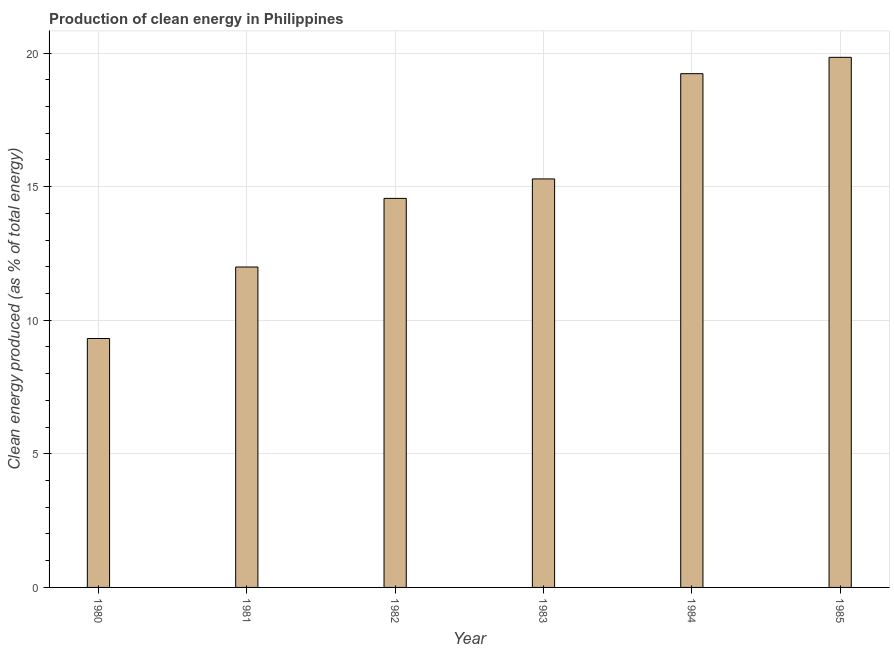What is the title of the graph?
Provide a succinct answer. Production of clean energy in Philippines. What is the label or title of the X-axis?
Offer a terse response. Year. What is the label or title of the Y-axis?
Keep it short and to the point. Clean energy produced (as % of total energy). What is the production of clean energy in 1982?
Offer a terse response. 14.56. Across all years, what is the maximum production of clean energy?
Ensure brevity in your answer.  19.84. Across all years, what is the minimum production of clean energy?
Provide a succinct answer. 9.32. In which year was the production of clean energy maximum?
Give a very brief answer. 1985. What is the sum of the production of clean energy?
Your answer should be very brief. 90.24. What is the difference between the production of clean energy in 1980 and 1985?
Your answer should be compact. -10.53. What is the average production of clean energy per year?
Provide a succinct answer. 15.04. What is the median production of clean energy?
Keep it short and to the point. 14.93. In how many years, is the production of clean energy greater than 6 %?
Keep it short and to the point. 6. What is the ratio of the production of clean energy in 1980 to that in 1981?
Offer a very short reply. 0.78. Is the production of clean energy in 1983 less than that in 1984?
Your answer should be very brief. Yes. What is the difference between the highest and the second highest production of clean energy?
Your answer should be compact. 0.61. Is the sum of the production of clean energy in 1981 and 1985 greater than the maximum production of clean energy across all years?
Provide a succinct answer. Yes. What is the difference between the highest and the lowest production of clean energy?
Keep it short and to the point. 10.52. Are all the bars in the graph horizontal?
Your answer should be compact. No. How many years are there in the graph?
Ensure brevity in your answer.  6. What is the difference between two consecutive major ticks on the Y-axis?
Ensure brevity in your answer.  5. Are the values on the major ticks of Y-axis written in scientific E-notation?
Your answer should be very brief. No. What is the Clean energy produced (as % of total energy) in 1980?
Provide a succinct answer. 9.32. What is the Clean energy produced (as % of total energy) of 1981?
Your answer should be very brief. 11.99. What is the Clean energy produced (as % of total energy) in 1982?
Your answer should be very brief. 14.56. What is the Clean energy produced (as % of total energy) in 1983?
Offer a terse response. 15.29. What is the Clean energy produced (as % of total energy) in 1984?
Offer a terse response. 19.23. What is the Clean energy produced (as % of total energy) of 1985?
Offer a very short reply. 19.84. What is the difference between the Clean energy produced (as % of total energy) in 1980 and 1981?
Your answer should be compact. -2.68. What is the difference between the Clean energy produced (as % of total energy) in 1980 and 1982?
Provide a succinct answer. -5.24. What is the difference between the Clean energy produced (as % of total energy) in 1980 and 1983?
Offer a very short reply. -5.97. What is the difference between the Clean energy produced (as % of total energy) in 1980 and 1984?
Provide a short and direct response. -9.91. What is the difference between the Clean energy produced (as % of total energy) in 1980 and 1985?
Make the answer very short. -10.52. What is the difference between the Clean energy produced (as % of total energy) in 1981 and 1982?
Offer a very short reply. -2.57. What is the difference between the Clean energy produced (as % of total energy) in 1981 and 1983?
Provide a succinct answer. -3.3. What is the difference between the Clean energy produced (as % of total energy) in 1981 and 1984?
Give a very brief answer. -7.24. What is the difference between the Clean energy produced (as % of total energy) in 1981 and 1985?
Your response must be concise. -7.85. What is the difference between the Clean energy produced (as % of total energy) in 1982 and 1983?
Provide a short and direct response. -0.73. What is the difference between the Clean energy produced (as % of total energy) in 1982 and 1984?
Keep it short and to the point. -4.67. What is the difference between the Clean energy produced (as % of total energy) in 1982 and 1985?
Give a very brief answer. -5.28. What is the difference between the Clean energy produced (as % of total energy) in 1983 and 1984?
Give a very brief answer. -3.94. What is the difference between the Clean energy produced (as % of total energy) in 1983 and 1985?
Ensure brevity in your answer.  -4.55. What is the difference between the Clean energy produced (as % of total energy) in 1984 and 1985?
Provide a succinct answer. -0.61. What is the ratio of the Clean energy produced (as % of total energy) in 1980 to that in 1981?
Keep it short and to the point. 0.78. What is the ratio of the Clean energy produced (as % of total energy) in 1980 to that in 1982?
Keep it short and to the point. 0.64. What is the ratio of the Clean energy produced (as % of total energy) in 1980 to that in 1983?
Offer a very short reply. 0.61. What is the ratio of the Clean energy produced (as % of total energy) in 1980 to that in 1984?
Give a very brief answer. 0.48. What is the ratio of the Clean energy produced (as % of total energy) in 1980 to that in 1985?
Make the answer very short. 0.47. What is the ratio of the Clean energy produced (as % of total energy) in 1981 to that in 1982?
Provide a succinct answer. 0.82. What is the ratio of the Clean energy produced (as % of total energy) in 1981 to that in 1983?
Provide a short and direct response. 0.78. What is the ratio of the Clean energy produced (as % of total energy) in 1981 to that in 1984?
Ensure brevity in your answer.  0.62. What is the ratio of the Clean energy produced (as % of total energy) in 1981 to that in 1985?
Your response must be concise. 0.6. What is the ratio of the Clean energy produced (as % of total energy) in 1982 to that in 1983?
Provide a short and direct response. 0.95. What is the ratio of the Clean energy produced (as % of total energy) in 1982 to that in 1984?
Offer a very short reply. 0.76. What is the ratio of the Clean energy produced (as % of total energy) in 1982 to that in 1985?
Your response must be concise. 0.73. What is the ratio of the Clean energy produced (as % of total energy) in 1983 to that in 1984?
Offer a very short reply. 0.8. What is the ratio of the Clean energy produced (as % of total energy) in 1983 to that in 1985?
Provide a succinct answer. 0.77. What is the ratio of the Clean energy produced (as % of total energy) in 1984 to that in 1985?
Provide a succinct answer. 0.97. 